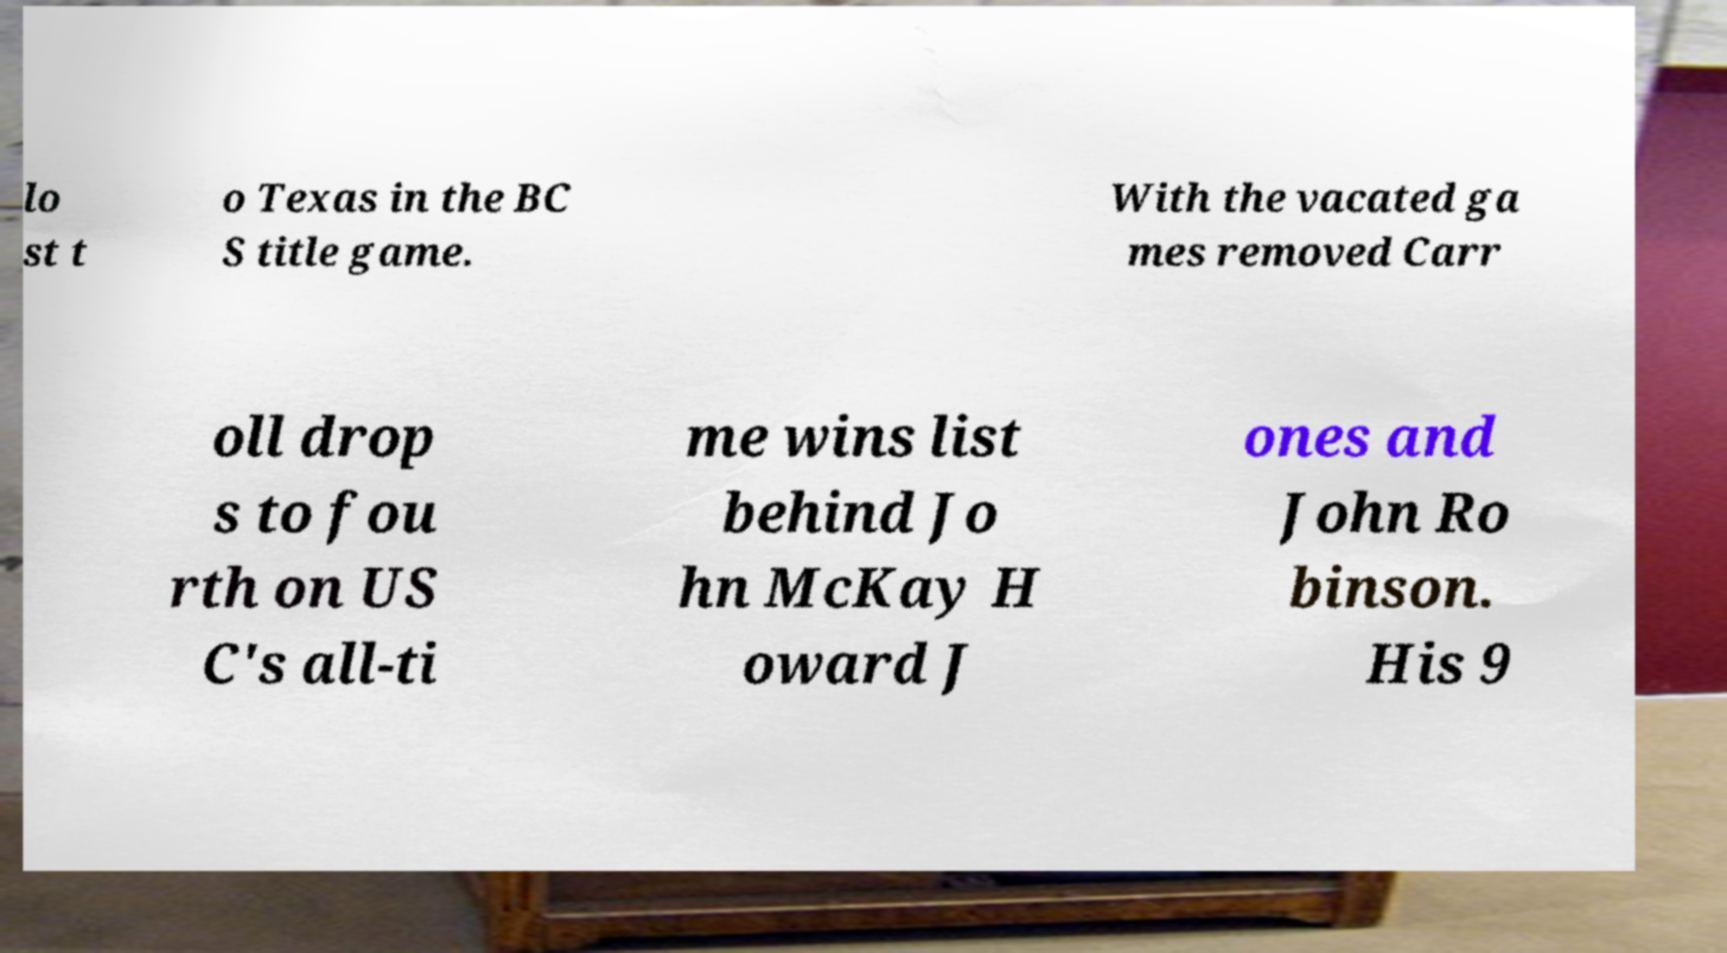For documentation purposes, I need the text within this image transcribed. Could you provide that? lo st t o Texas in the BC S title game. With the vacated ga mes removed Carr oll drop s to fou rth on US C's all-ti me wins list behind Jo hn McKay H oward J ones and John Ro binson. His 9 